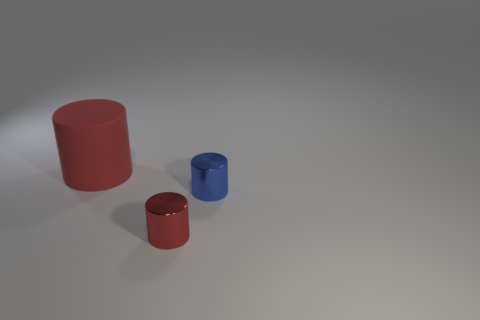Add 3 tiny things. How many objects exist? 6 Subtract all small blue cylinders. Subtract all blue metal objects. How many objects are left? 1 Add 2 large rubber cylinders. How many large rubber cylinders are left? 3 Add 1 large matte things. How many large matte things exist? 2 Subtract 0 green balls. How many objects are left? 3 